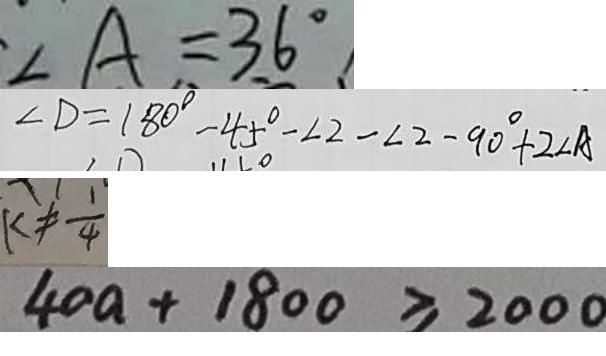<formula> <loc_0><loc_0><loc_500><loc_500>\angle A = 3 6 ^ { \circ } 
 \angle D = 1 8 0 ^ { \circ } - 4 5 ^ { \circ } - \angle 2 - \angle 2 - 9 0 ^ { \circ } + 2 \angle A 
 k \neq \frac { 1 } { 4 } 
 4 0 a + 1 8 0 0 \geq 2 0 0 0</formula> 